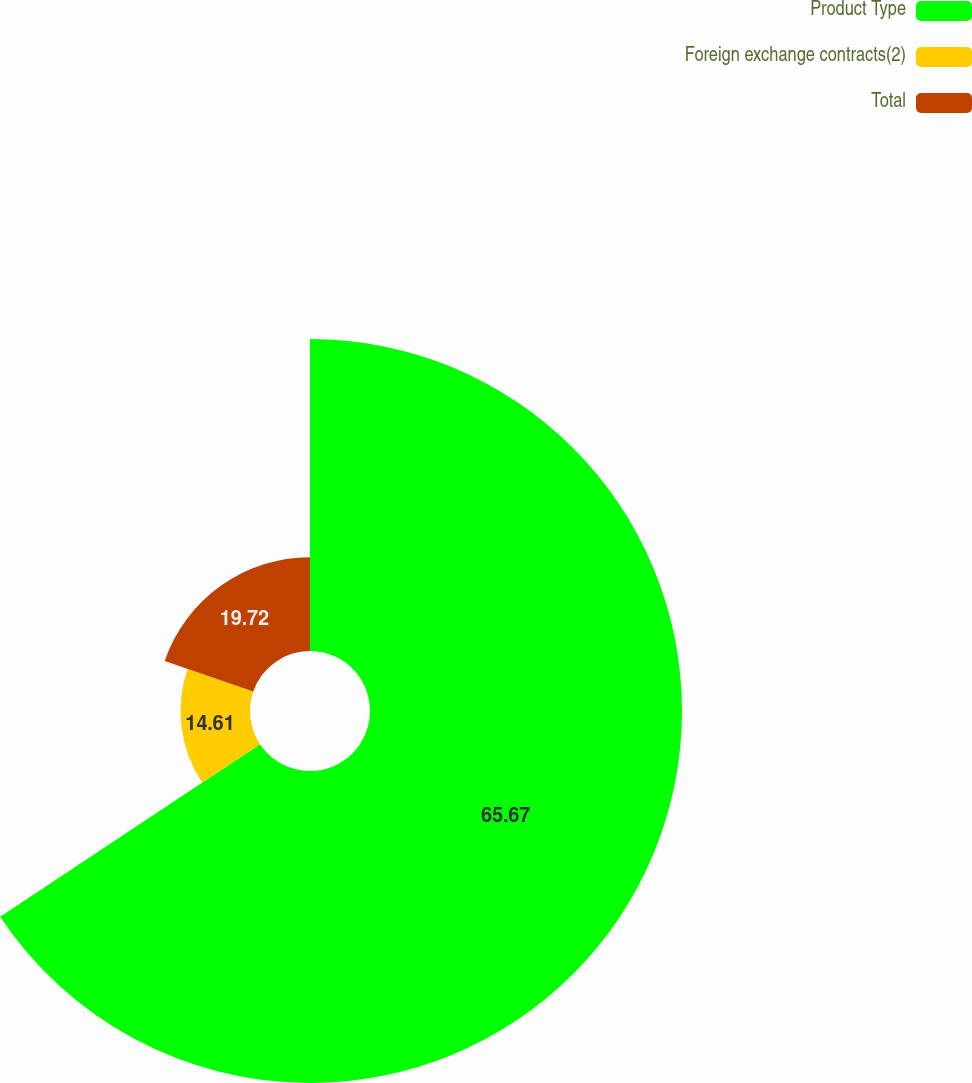Convert chart. <chart><loc_0><loc_0><loc_500><loc_500><pie_chart><fcel>Product Type<fcel>Foreign exchange contracts(2)<fcel>Total<nl><fcel>65.67%<fcel>14.61%<fcel>19.72%<nl></chart> 